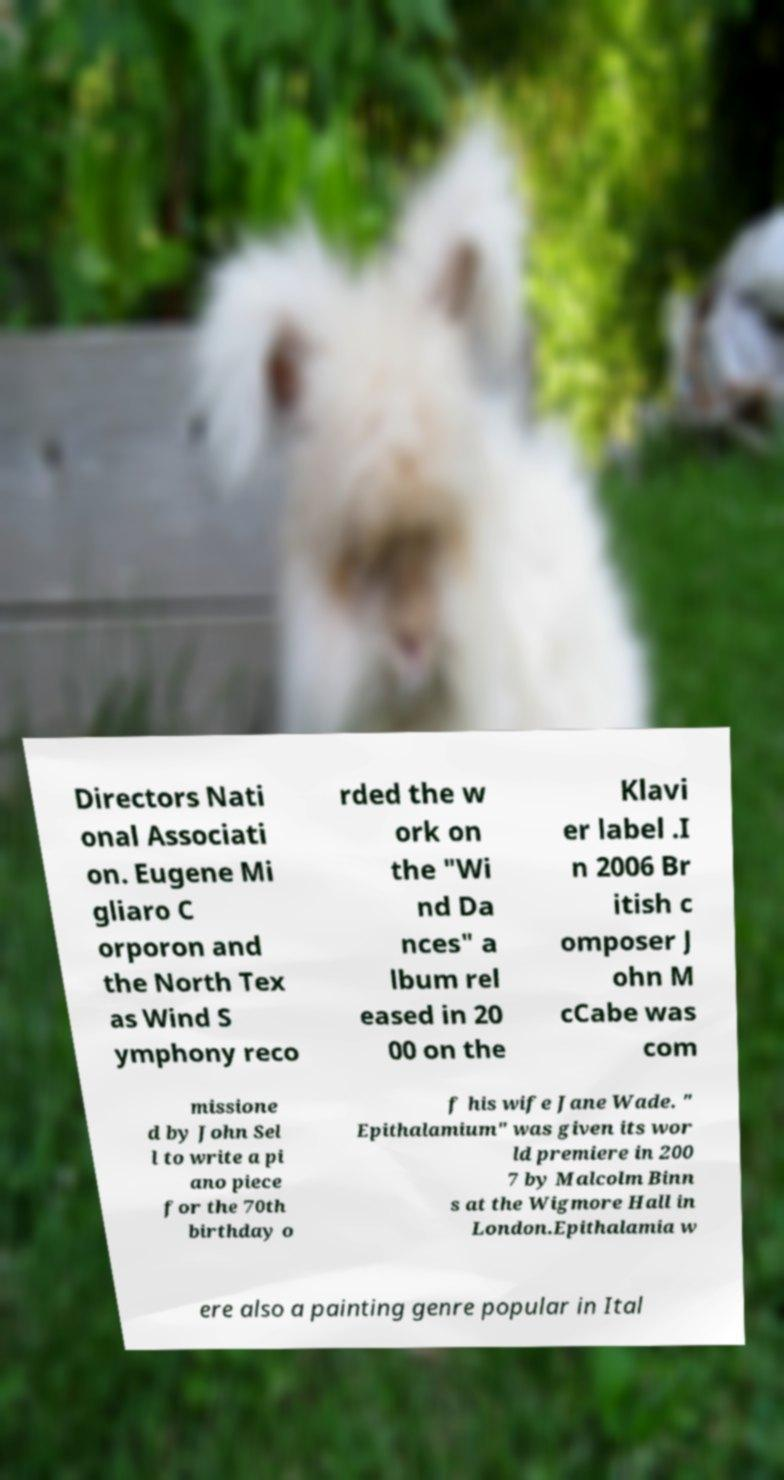Please read and relay the text visible in this image. What does it say? Directors Nati onal Associati on. Eugene Mi gliaro C orporon and the North Tex as Wind S ymphony reco rded the w ork on the "Wi nd Da nces" a lbum rel eased in 20 00 on the Klavi er label .I n 2006 Br itish c omposer J ohn M cCabe was com missione d by John Sel l to write a pi ano piece for the 70th birthday o f his wife Jane Wade. " Epithalamium" was given its wor ld premiere in 200 7 by Malcolm Binn s at the Wigmore Hall in London.Epithalamia w ere also a painting genre popular in Ital 